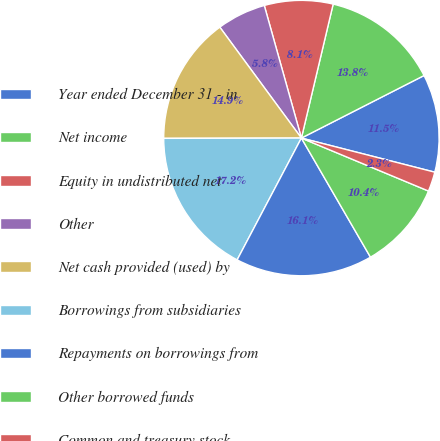Convert chart. <chart><loc_0><loc_0><loc_500><loc_500><pie_chart><fcel>Year ended December 31 - in<fcel>Net income<fcel>Equity in undistributed net<fcel>Other<fcel>Net cash provided (used) by<fcel>Borrowings from subsidiaries<fcel>Repayments on borrowings from<fcel>Other borrowed funds<fcel>Common and treasury stock<nl><fcel>11.49%<fcel>13.79%<fcel>8.05%<fcel>5.75%<fcel>14.94%<fcel>17.24%<fcel>16.09%<fcel>10.35%<fcel>2.3%<nl></chart> 